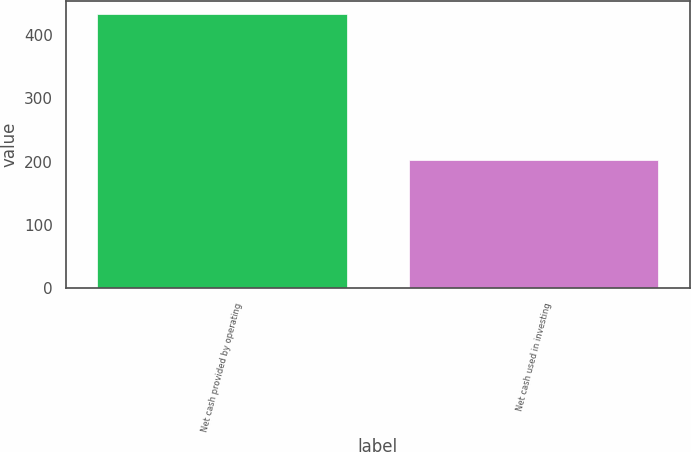Convert chart. <chart><loc_0><loc_0><loc_500><loc_500><bar_chart><fcel>Net cash provided by operating<fcel>Net cash used in investing<nl><fcel>432.9<fcel>202.5<nl></chart> 